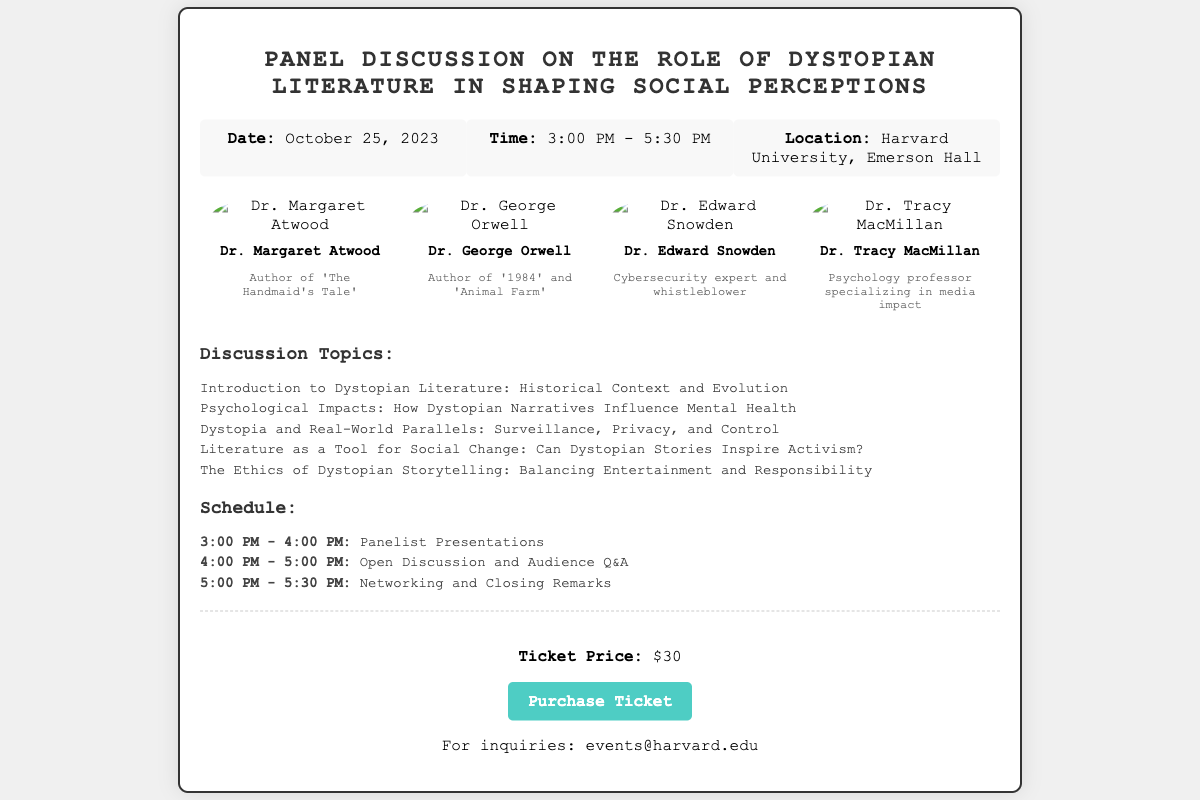What is the date of the event? The date of the event is stated in the event details section of the document.
Answer: October 25, 2023 What time does the event start? The starting time of the event is specified in the event details section.
Answer: 3:00 PM Who is the author of 'The Handmaid's Tale'? The panelist information provides the names and works of each panelist.
Answer: Dr. Margaret Atwood How long is the panelist presentations scheduled for? The schedule section indicates the duration of the panelist presentations.
Answer: 1 hour What is the ticket price? The ticket price is mentioned in the ticket information section of the document.
Answer: $30 Which topic discusses the psychological impacts of dystopian narratives? The topics section lists various discussion topics including their focus areas.
Answer: Psychological Impacts: How Dystopian Narratives Influence Mental Health What is the location of the event? The location is detailed in the event details section of the document.
Answer: Harvard University, Emerson Hall What is the last activity scheduled for this event? The schedule section outlines the activities, and the last one is noted.
Answer: Networking and Closing Remarks 